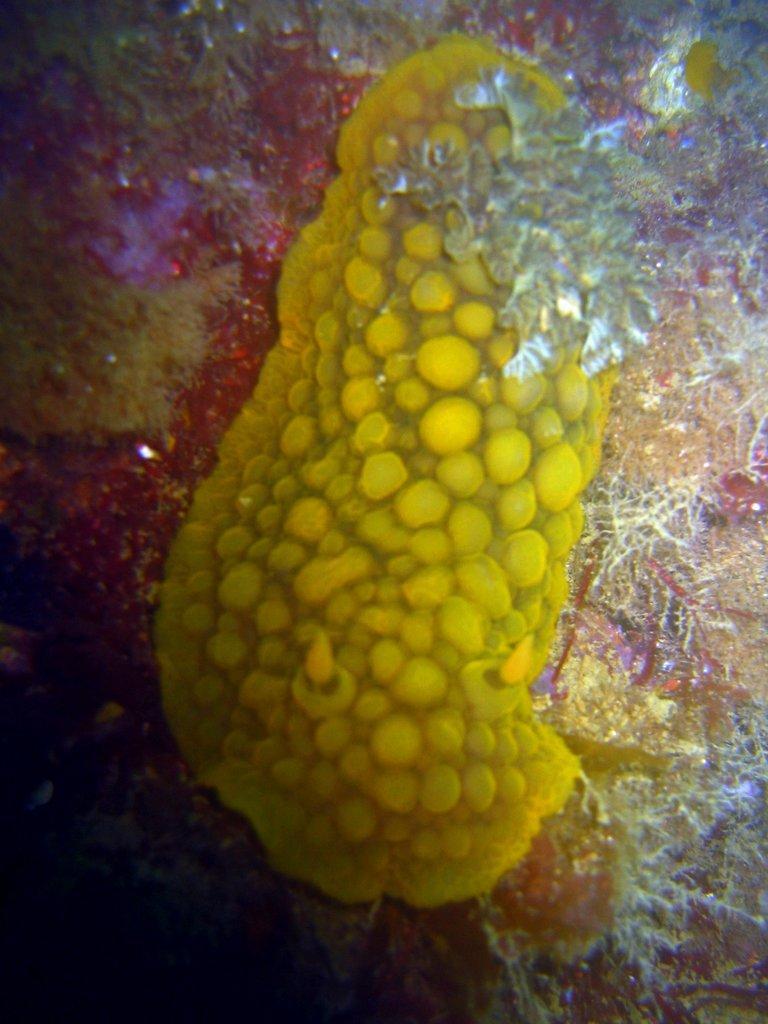Could you give a brief overview of what you see in this image? In this image we can see the microorganisms in the water. 